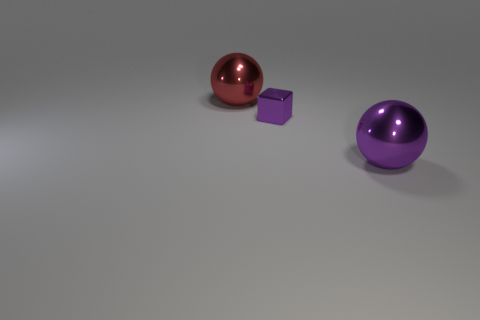What size is the other object that is the same shape as the big purple metallic object?
Offer a very short reply. Large. There is another large thing that is the same shape as the red object; what color is it?
Your answer should be very brief. Purple. Is the size of the metallic block the same as the ball behind the big purple object?
Provide a succinct answer. No. How many objects are either large objects that are in front of the red metal ball or things behind the big purple object?
Provide a succinct answer. 3. Are there more metal things behind the small purple thing than small purple spheres?
Ensure brevity in your answer.  Yes. How many other objects are the same size as the red metallic object?
Your answer should be very brief. 1. Does the purple block to the left of the purple metallic sphere have the same size as the purple metal object that is in front of the cube?
Make the answer very short. No. What is the size of the purple metal sphere in front of the tiny metallic block?
Keep it short and to the point. Large. There is a ball that is right of the purple metallic thing that is behind the big purple metallic object; what is its size?
Your response must be concise. Large. There is another sphere that is the same size as the purple metallic sphere; what is its material?
Your answer should be compact. Metal. 